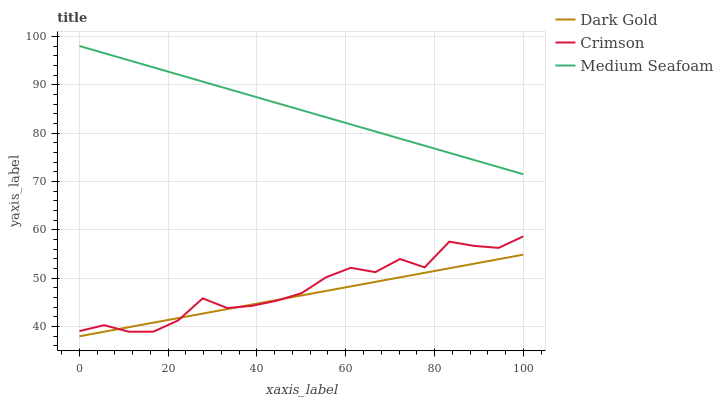Does Dark Gold have the minimum area under the curve?
Answer yes or no. Yes. Does Medium Seafoam have the maximum area under the curve?
Answer yes or no. Yes. Does Medium Seafoam have the minimum area under the curve?
Answer yes or no. No. Does Dark Gold have the maximum area under the curve?
Answer yes or no. No. Is Medium Seafoam the smoothest?
Answer yes or no. Yes. Is Crimson the roughest?
Answer yes or no. Yes. Is Dark Gold the smoothest?
Answer yes or no. No. Is Dark Gold the roughest?
Answer yes or no. No. Does Dark Gold have the lowest value?
Answer yes or no. Yes. Does Medium Seafoam have the lowest value?
Answer yes or no. No. Does Medium Seafoam have the highest value?
Answer yes or no. Yes. Does Dark Gold have the highest value?
Answer yes or no. No. Is Dark Gold less than Medium Seafoam?
Answer yes or no. Yes. Is Medium Seafoam greater than Dark Gold?
Answer yes or no. Yes. Does Dark Gold intersect Crimson?
Answer yes or no. Yes. Is Dark Gold less than Crimson?
Answer yes or no. No. Is Dark Gold greater than Crimson?
Answer yes or no. No. Does Dark Gold intersect Medium Seafoam?
Answer yes or no. No. 